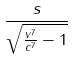Convert formula to latex. <formula><loc_0><loc_0><loc_500><loc_500>\frac { s } { \sqrt { \frac { v ^ { 7 } } { c ^ { 7 } } - 1 } }</formula> 